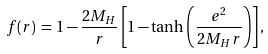Convert formula to latex. <formula><loc_0><loc_0><loc_500><loc_500>f ( r ) \, = \, 1 - { \frac { 2 M _ { H } } { r } } \left [ 1 - \tanh \left ( { \frac { e ^ { 2 } } { 2 M _ { H } r } } \right ) \right ] ,</formula> 